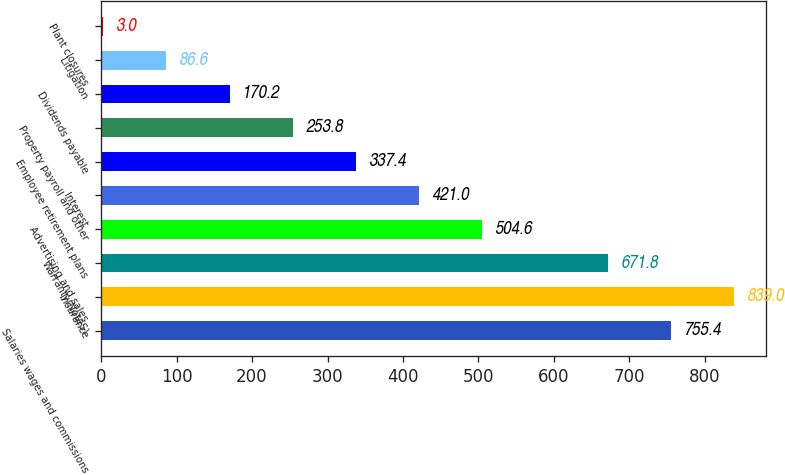Convert chart. <chart><loc_0><loc_0><loc_500><loc_500><bar_chart><fcel>Salaries wages and commissions<fcel>Insurance<fcel>Warranty(NoteS)<fcel>Advertising and sales<fcel>Interest<fcel>Employee retirement plans<fcel>Property payroll and other<fcel>Dividends payable<fcel>Litigation<fcel>Plant closures<nl><fcel>755.4<fcel>839<fcel>671.8<fcel>504.6<fcel>421<fcel>337.4<fcel>253.8<fcel>170.2<fcel>86.6<fcel>3<nl></chart> 